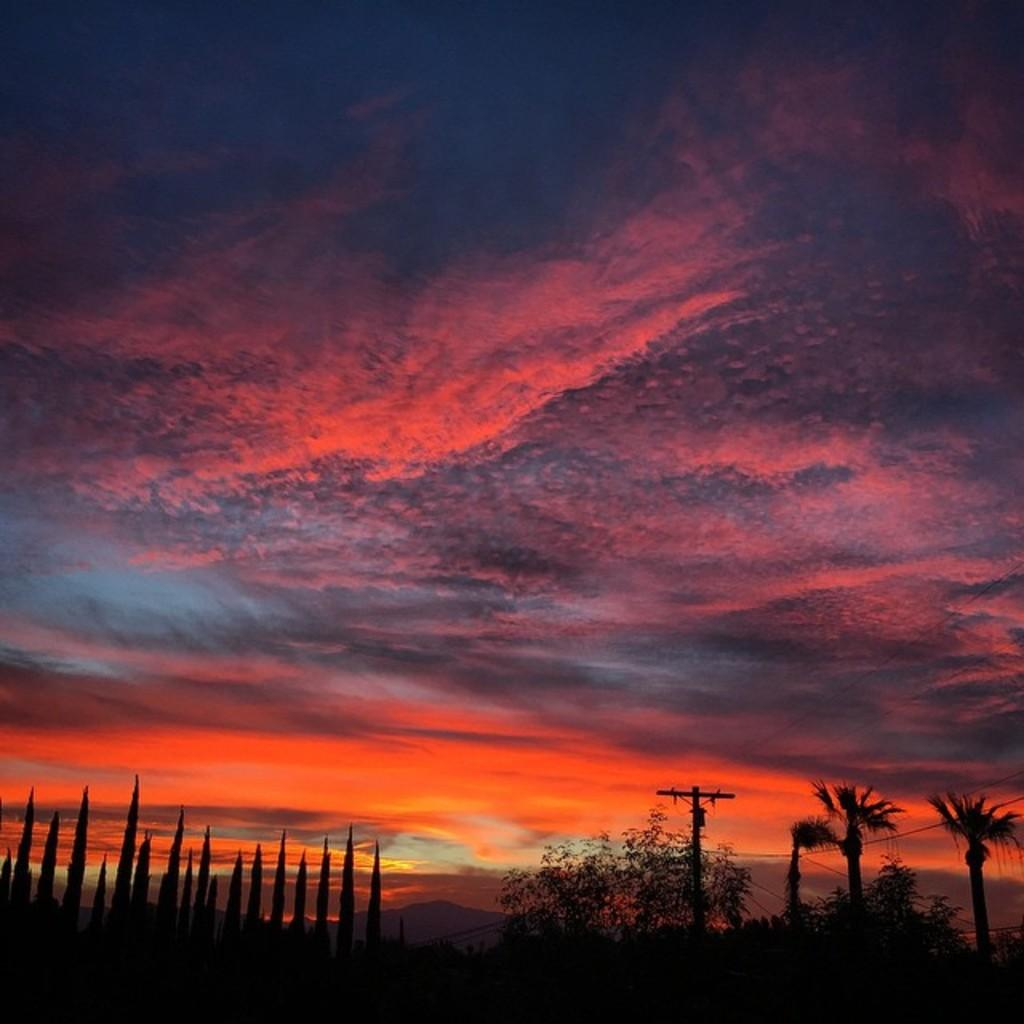What can be seen in the sky in the image? The sky with clouds is visible in the image. What type of structures are present in the image? There are buildings in the image. What natural features can be seen in the image? Hills are present in the image. What man-made object is visible in the image? An electric pole is visible in the image. What is connected to the electric pole in the image? Electric cables are present in the image. What type of vegetation is visible in the image? Plants are visible in the image. What is the reason for the cattle to be present in the image? There are no cattle present in the image. How does the image show the emotion of hate? The image does not depict any emotions, including hate. 